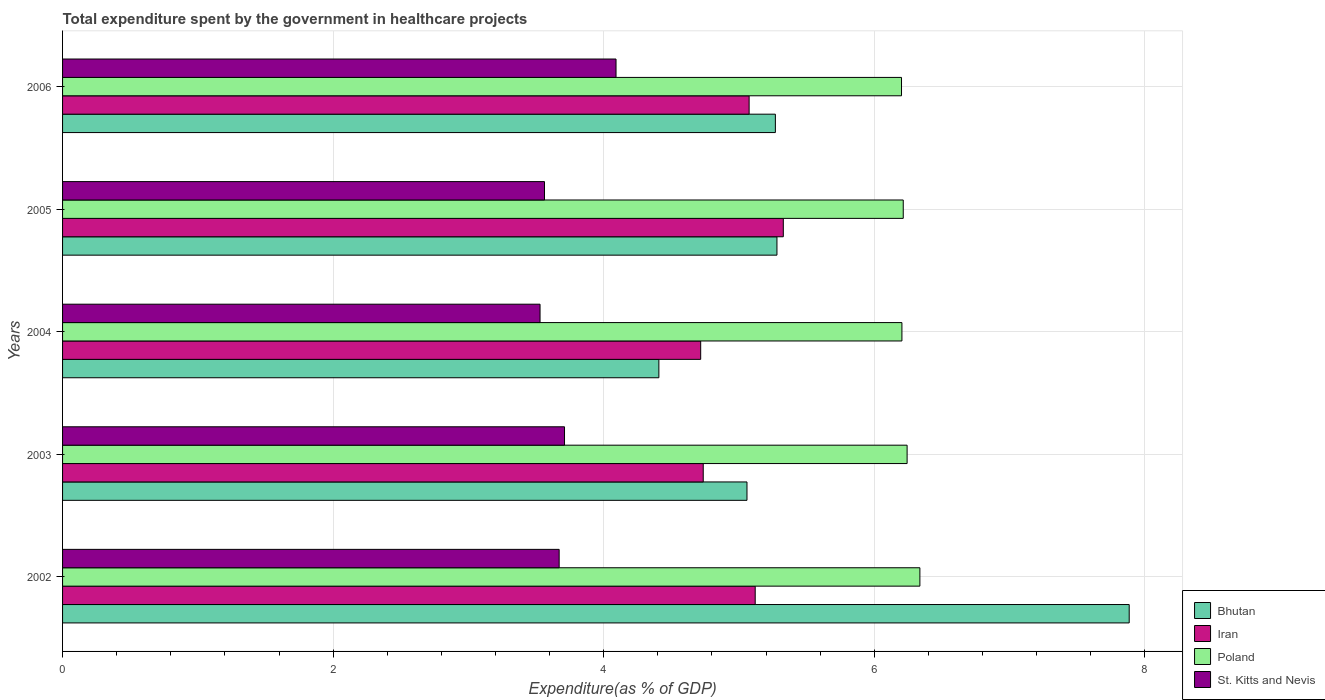How many different coloured bars are there?
Provide a succinct answer. 4. How many groups of bars are there?
Provide a succinct answer. 5. Are the number of bars per tick equal to the number of legend labels?
Give a very brief answer. Yes. How many bars are there on the 5th tick from the top?
Your answer should be very brief. 4. What is the label of the 4th group of bars from the top?
Make the answer very short. 2003. What is the total expenditure spent by the government in healthcare projects in Poland in 2006?
Your answer should be very brief. 6.2. Across all years, what is the maximum total expenditure spent by the government in healthcare projects in Poland?
Your answer should be very brief. 6.34. Across all years, what is the minimum total expenditure spent by the government in healthcare projects in St. Kitts and Nevis?
Your answer should be compact. 3.53. In which year was the total expenditure spent by the government in healthcare projects in Bhutan minimum?
Your answer should be compact. 2004. What is the total total expenditure spent by the government in healthcare projects in Bhutan in the graph?
Make the answer very short. 27.9. What is the difference between the total expenditure spent by the government in healthcare projects in Iran in 2002 and that in 2005?
Make the answer very short. -0.21. What is the difference between the total expenditure spent by the government in healthcare projects in Iran in 2005 and the total expenditure spent by the government in healthcare projects in Bhutan in 2002?
Provide a succinct answer. -2.56. What is the average total expenditure spent by the government in healthcare projects in Iran per year?
Provide a short and direct response. 4.99. In the year 2003, what is the difference between the total expenditure spent by the government in healthcare projects in Bhutan and total expenditure spent by the government in healthcare projects in St. Kitts and Nevis?
Give a very brief answer. 1.35. What is the ratio of the total expenditure spent by the government in healthcare projects in Iran in 2003 to that in 2006?
Your answer should be very brief. 0.93. Is the total expenditure spent by the government in healthcare projects in Bhutan in 2004 less than that in 2005?
Keep it short and to the point. Yes. What is the difference between the highest and the second highest total expenditure spent by the government in healthcare projects in Iran?
Your answer should be very brief. 0.21. What is the difference between the highest and the lowest total expenditure spent by the government in healthcare projects in Iran?
Offer a terse response. 0.61. In how many years, is the total expenditure spent by the government in healthcare projects in Bhutan greater than the average total expenditure spent by the government in healthcare projects in Bhutan taken over all years?
Your answer should be very brief. 1. What does the 1st bar from the top in 2004 represents?
Ensure brevity in your answer.  St. Kitts and Nevis. What does the 3rd bar from the bottom in 2005 represents?
Provide a short and direct response. Poland. Are all the bars in the graph horizontal?
Make the answer very short. Yes. How many years are there in the graph?
Keep it short and to the point. 5. What is the difference between two consecutive major ticks on the X-axis?
Provide a short and direct response. 2. Are the values on the major ticks of X-axis written in scientific E-notation?
Make the answer very short. No. Where does the legend appear in the graph?
Your answer should be compact. Bottom right. How are the legend labels stacked?
Give a very brief answer. Vertical. What is the title of the graph?
Give a very brief answer. Total expenditure spent by the government in healthcare projects. What is the label or title of the X-axis?
Offer a terse response. Expenditure(as % of GDP). What is the Expenditure(as % of GDP) in Bhutan in 2002?
Your response must be concise. 7.88. What is the Expenditure(as % of GDP) in Iran in 2002?
Give a very brief answer. 5.12. What is the Expenditure(as % of GDP) in Poland in 2002?
Your answer should be compact. 6.34. What is the Expenditure(as % of GDP) of St. Kitts and Nevis in 2002?
Provide a short and direct response. 3.67. What is the Expenditure(as % of GDP) of Bhutan in 2003?
Give a very brief answer. 5.06. What is the Expenditure(as % of GDP) in Iran in 2003?
Make the answer very short. 4.74. What is the Expenditure(as % of GDP) in Poland in 2003?
Ensure brevity in your answer.  6.24. What is the Expenditure(as % of GDP) in St. Kitts and Nevis in 2003?
Your answer should be compact. 3.71. What is the Expenditure(as % of GDP) in Bhutan in 2004?
Your response must be concise. 4.41. What is the Expenditure(as % of GDP) of Iran in 2004?
Provide a short and direct response. 4.72. What is the Expenditure(as % of GDP) of Poland in 2004?
Offer a terse response. 6.2. What is the Expenditure(as % of GDP) in St. Kitts and Nevis in 2004?
Ensure brevity in your answer.  3.53. What is the Expenditure(as % of GDP) of Bhutan in 2005?
Provide a succinct answer. 5.28. What is the Expenditure(as % of GDP) in Iran in 2005?
Make the answer very short. 5.33. What is the Expenditure(as % of GDP) of Poland in 2005?
Your answer should be compact. 6.21. What is the Expenditure(as % of GDP) in St. Kitts and Nevis in 2005?
Give a very brief answer. 3.56. What is the Expenditure(as % of GDP) of Bhutan in 2006?
Offer a terse response. 5.27. What is the Expenditure(as % of GDP) in Iran in 2006?
Make the answer very short. 5.07. What is the Expenditure(as % of GDP) in Poland in 2006?
Ensure brevity in your answer.  6.2. What is the Expenditure(as % of GDP) of St. Kitts and Nevis in 2006?
Offer a very short reply. 4.09. Across all years, what is the maximum Expenditure(as % of GDP) in Bhutan?
Your answer should be very brief. 7.88. Across all years, what is the maximum Expenditure(as % of GDP) of Iran?
Ensure brevity in your answer.  5.33. Across all years, what is the maximum Expenditure(as % of GDP) of Poland?
Give a very brief answer. 6.34. Across all years, what is the maximum Expenditure(as % of GDP) of St. Kitts and Nevis?
Your response must be concise. 4.09. Across all years, what is the minimum Expenditure(as % of GDP) in Bhutan?
Your response must be concise. 4.41. Across all years, what is the minimum Expenditure(as % of GDP) of Iran?
Your answer should be very brief. 4.72. Across all years, what is the minimum Expenditure(as % of GDP) of Poland?
Give a very brief answer. 6.2. Across all years, what is the minimum Expenditure(as % of GDP) of St. Kitts and Nevis?
Your answer should be very brief. 3.53. What is the total Expenditure(as % of GDP) in Bhutan in the graph?
Your answer should be very brief. 27.9. What is the total Expenditure(as % of GDP) in Iran in the graph?
Provide a short and direct response. 24.97. What is the total Expenditure(as % of GDP) of Poland in the graph?
Give a very brief answer. 31.2. What is the total Expenditure(as % of GDP) of St. Kitts and Nevis in the graph?
Your answer should be compact. 18.56. What is the difference between the Expenditure(as % of GDP) of Bhutan in 2002 and that in 2003?
Provide a succinct answer. 2.83. What is the difference between the Expenditure(as % of GDP) of Iran in 2002 and that in 2003?
Give a very brief answer. 0.38. What is the difference between the Expenditure(as % of GDP) of Poland in 2002 and that in 2003?
Keep it short and to the point. 0.09. What is the difference between the Expenditure(as % of GDP) of St. Kitts and Nevis in 2002 and that in 2003?
Your answer should be very brief. -0.04. What is the difference between the Expenditure(as % of GDP) in Bhutan in 2002 and that in 2004?
Provide a short and direct response. 3.48. What is the difference between the Expenditure(as % of GDP) in Iran in 2002 and that in 2004?
Your answer should be very brief. 0.4. What is the difference between the Expenditure(as % of GDP) in Poland in 2002 and that in 2004?
Offer a terse response. 0.13. What is the difference between the Expenditure(as % of GDP) in St. Kitts and Nevis in 2002 and that in 2004?
Make the answer very short. 0.14. What is the difference between the Expenditure(as % of GDP) of Bhutan in 2002 and that in 2005?
Ensure brevity in your answer.  2.6. What is the difference between the Expenditure(as % of GDP) of Iran in 2002 and that in 2005?
Keep it short and to the point. -0.21. What is the difference between the Expenditure(as % of GDP) of Poland in 2002 and that in 2005?
Provide a succinct answer. 0.12. What is the difference between the Expenditure(as % of GDP) of St. Kitts and Nevis in 2002 and that in 2005?
Offer a terse response. 0.11. What is the difference between the Expenditure(as % of GDP) in Bhutan in 2002 and that in 2006?
Your response must be concise. 2.62. What is the difference between the Expenditure(as % of GDP) of Iran in 2002 and that in 2006?
Give a very brief answer. 0.04. What is the difference between the Expenditure(as % of GDP) of Poland in 2002 and that in 2006?
Offer a terse response. 0.14. What is the difference between the Expenditure(as % of GDP) of St. Kitts and Nevis in 2002 and that in 2006?
Your answer should be compact. -0.42. What is the difference between the Expenditure(as % of GDP) of Bhutan in 2003 and that in 2004?
Offer a terse response. 0.65. What is the difference between the Expenditure(as % of GDP) in Iran in 2003 and that in 2004?
Your answer should be compact. 0.02. What is the difference between the Expenditure(as % of GDP) in Poland in 2003 and that in 2004?
Offer a terse response. 0.04. What is the difference between the Expenditure(as % of GDP) of St. Kitts and Nevis in 2003 and that in 2004?
Keep it short and to the point. 0.18. What is the difference between the Expenditure(as % of GDP) of Bhutan in 2003 and that in 2005?
Provide a succinct answer. -0.22. What is the difference between the Expenditure(as % of GDP) in Iran in 2003 and that in 2005?
Your answer should be compact. -0.59. What is the difference between the Expenditure(as % of GDP) in Poland in 2003 and that in 2005?
Your answer should be very brief. 0.03. What is the difference between the Expenditure(as % of GDP) of St. Kitts and Nevis in 2003 and that in 2005?
Offer a terse response. 0.15. What is the difference between the Expenditure(as % of GDP) of Bhutan in 2003 and that in 2006?
Provide a short and direct response. -0.21. What is the difference between the Expenditure(as % of GDP) in Iran in 2003 and that in 2006?
Provide a succinct answer. -0.34. What is the difference between the Expenditure(as % of GDP) in Poland in 2003 and that in 2006?
Keep it short and to the point. 0.04. What is the difference between the Expenditure(as % of GDP) of St. Kitts and Nevis in 2003 and that in 2006?
Offer a terse response. -0.38. What is the difference between the Expenditure(as % of GDP) of Bhutan in 2004 and that in 2005?
Keep it short and to the point. -0.87. What is the difference between the Expenditure(as % of GDP) of Iran in 2004 and that in 2005?
Give a very brief answer. -0.61. What is the difference between the Expenditure(as % of GDP) in Poland in 2004 and that in 2005?
Provide a succinct answer. -0.01. What is the difference between the Expenditure(as % of GDP) in St. Kitts and Nevis in 2004 and that in 2005?
Ensure brevity in your answer.  -0.03. What is the difference between the Expenditure(as % of GDP) in Bhutan in 2004 and that in 2006?
Provide a short and direct response. -0.86. What is the difference between the Expenditure(as % of GDP) in Iran in 2004 and that in 2006?
Offer a terse response. -0.36. What is the difference between the Expenditure(as % of GDP) in Poland in 2004 and that in 2006?
Provide a succinct answer. 0. What is the difference between the Expenditure(as % of GDP) in St. Kitts and Nevis in 2004 and that in 2006?
Keep it short and to the point. -0.56. What is the difference between the Expenditure(as % of GDP) of Bhutan in 2005 and that in 2006?
Offer a very short reply. 0.01. What is the difference between the Expenditure(as % of GDP) in Iran in 2005 and that in 2006?
Provide a short and direct response. 0.25. What is the difference between the Expenditure(as % of GDP) of Poland in 2005 and that in 2006?
Your response must be concise. 0.01. What is the difference between the Expenditure(as % of GDP) in St. Kitts and Nevis in 2005 and that in 2006?
Your answer should be compact. -0.53. What is the difference between the Expenditure(as % of GDP) of Bhutan in 2002 and the Expenditure(as % of GDP) of Iran in 2003?
Your response must be concise. 3.15. What is the difference between the Expenditure(as % of GDP) of Bhutan in 2002 and the Expenditure(as % of GDP) of Poland in 2003?
Provide a short and direct response. 1.64. What is the difference between the Expenditure(as % of GDP) in Bhutan in 2002 and the Expenditure(as % of GDP) in St. Kitts and Nevis in 2003?
Offer a terse response. 4.17. What is the difference between the Expenditure(as % of GDP) in Iran in 2002 and the Expenditure(as % of GDP) in Poland in 2003?
Your response must be concise. -1.12. What is the difference between the Expenditure(as % of GDP) of Iran in 2002 and the Expenditure(as % of GDP) of St. Kitts and Nevis in 2003?
Keep it short and to the point. 1.41. What is the difference between the Expenditure(as % of GDP) of Poland in 2002 and the Expenditure(as % of GDP) of St. Kitts and Nevis in 2003?
Offer a very short reply. 2.63. What is the difference between the Expenditure(as % of GDP) in Bhutan in 2002 and the Expenditure(as % of GDP) in Iran in 2004?
Ensure brevity in your answer.  3.17. What is the difference between the Expenditure(as % of GDP) of Bhutan in 2002 and the Expenditure(as % of GDP) of Poland in 2004?
Your response must be concise. 1.68. What is the difference between the Expenditure(as % of GDP) in Bhutan in 2002 and the Expenditure(as % of GDP) in St. Kitts and Nevis in 2004?
Give a very brief answer. 4.35. What is the difference between the Expenditure(as % of GDP) of Iran in 2002 and the Expenditure(as % of GDP) of Poland in 2004?
Keep it short and to the point. -1.08. What is the difference between the Expenditure(as % of GDP) in Iran in 2002 and the Expenditure(as % of GDP) in St. Kitts and Nevis in 2004?
Ensure brevity in your answer.  1.59. What is the difference between the Expenditure(as % of GDP) of Poland in 2002 and the Expenditure(as % of GDP) of St. Kitts and Nevis in 2004?
Offer a very short reply. 2.81. What is the difference between the Expenditure(as % of GDP) in Bhutan in 2002 and the Expenditure(as % of GDP) in Iran in 2005?
Your answer should be very brief. 2.56. What is the difference between the Expenditure(as % of GDP) of Bhutan in 2002 and the Expenditure(as % of GDP) of Poland in 2005?
Give a very brief answer. 1.67. What is the difference between the Expenditure(as % of GDP) in Bhutan in 2002 and the Expenditure(as % of GDP) in St. Kitts and Nevis in 2005?
Make the answer very short. 4.32. What is the difference between the Expenditure(as % of GDP) of Iran in 2002 and the Expenditure(as % of GDP) of Poland in 2005?
Your response must be concise. -1.09. What is the difference between the Expenditure(as % of GDP) in Iran in 2002 and the Expenditure(as % of GDP) in St. Kitts and Nevis in 2005?
Keep it short and to the point. 1.56. What is the difference between the Expenditure(as % of GDP) in Poland in 2002 and the Expenditure(as % of GDP) in St. Kitts and Nevis in 2005?
Provide a succinct answer. 2.77. What is the difference between the Expenditure(as % of GDP) of Bhutan in 2002 and the Expenditure(as % of GDP) of Iran in 2006?
Make the answer very short. 2.81. What is the difference between the Expenditure(as % of GDP) in Bhutan in 2002 and the Expenditure(as % of GDP) in Poland in 2006?
Give a very brief answer. 1.68. What is the difference between the Expenditure(as % of GDP) in Bhutan in 2002 and the Expenditure(as % of GDP) in St. Kitts and Nevis in 2006?
Keep it short and to the point. 3.79. What is the difference between the Expenditure(as % of GDP) in Iran in 2002 and the Expenditure(as % of GDP) in Poland in 2006?
Offer a very short reply. -1.08. What is the difference between the Expenditure(as % of GDP) in Iran in 2002 and the Expenditure(as % of GDP) in St. Kitts and Nevis in 2006?
Offer a terse response. 1.03. What is the difference between the Expenditure(as % of GDP) of Poland in 2002 and the Expenditure(as % of GDP) of St. Kitts and Nevis in 2006?
Give a very brief answer. 2.25. What is the difference between the Expenditure(as % of GDP) of Bhutan in 2003 and the Expenditure(as % of GDP) of Iran in 2004?
Keep it short and to the point. 0.34. What is the difference between the Expenditure(as % of GDP) of Bhutan in 2003 and the Expenditure(as % of GDP) of Poland in 2004?
Your answer should be very brief. -1.15. What is the difference between the Expenditure(as % of GDP) in Bhutan in 2003 and the Expenditure(as % of GDP) in St. Kitts and Nevis in 2004?
Provide a succinct answer. 1.53. What is the difference between the Expenditure(as % of GDP) of Iran in 2003 and the Expenditure(as % of GDP) of Poland in 2004?
Make the answer very short. -1.47. What is the difference between the Expenditure(as % of GDP) in Iran in 2003 and the Expenditure(as % of GDP) in St. Kitts and Nevis in 2004?
Keep it short and to the point. 1.21. What is the difference between the Expenditure(as % of GDP) of Poland in 2003 and the Expenditure(as % of GDP) of St. Kitts and Nevis in 2004?
Offer a terse response. 2.71. What is the difference between the Expenditure(as % of GDP) of Bhutan in 2003 and the Expenditure(as % of GDP) of Iran in 2005?
Your answer should be compact. -0.27. What is the difference between the Expenditure(as % of GDP) of Bhutan in 2003 and the Expenditure(as % of GDP) of Poland in 2005?
Give a very brief answer. -1.16. What is the difference between the Expenditure(as % of GDP) in Bhutan in 2003 and the Expenditure(as % of GDP) in St. Kitts and Nevis in 2005?
Keep it short and to the point. 1.5. What is the difference between the Expenditure(as % of GDP) in Iran in 2003 and the Expenditure(as % of GDP) in Poland in 2005?
Offer a very short reply. -1.48. What is the difference between the Expenditure(as % of GDP) of Iran in 2003 and the Expenditure(as % of GDP) of St. Kitts and Nevis in 2005?
Provide a succinct answer. 1.17. What is the difference between the Expenditure(as % of GDP) of Poland in 2003 and the Expenditure(as % of GDP) of St. Kitts and Nevis in 2005?
Provide a succinct answer. 2.68. What is the difference between the Expenditure(as % of GDP) of Bhutan in 2003 and the Expenditure(as % of GDP) of Iran in 2006?
Give a very brief answer. -0.02. What is the difference between the Expenditure(as % of GDP) in Bhutan in 2003 and the Expenditure(as % of GDP) in Poland in 2006?
Provide a short and direct response. -1.14. What is the difference between the Expenditure(as % of GDP) in Bhutan in 2003 and the Expenditure(as % of GDP) in St. Kitts and Nevis in 2006?
Provide a short and direct response. 0.97. What is the difference between the Expenditure(as % of GDP) of Iran in 2003 and the Expenditure(as % of GDP) of Poland in 2006?
Provide a succinct answer. -1.47. What is the difference between the Expenditure(as % of GDP) in Iran in 2003 and the Expenditure(as % of GDP) in St. Kitts and Nevis in 2006?
Offer a very short reply. 0.64. What is the difference between the Expenditure(as % of GDP) of Poland in 2003 and the Expenditure(as % of GDP) of St. Kitts and Nevis in 2006?
Provide a succinct answer. 2.15. What is the difference between the Expenditure(as % of GDP) of Bhutan in 2004 and the Expenditure(as % of GDP) of Iran in 2005?
Offer a terse response. -0.92. What is the difference between the Expenditure(as % of GDP) of Bhutan in 2004 and the Expenditure(as % of GDP) of Poland in 2005?
Provide a succinct answer. -1.81. What is the difference between the Expenditure(as % of GDP) in Bhutan in 2004 and the Expenditure(as % of GDP) in St. Kitts and Nevis in 2005?
Give a very brief answer. 0.85. What is the difference between the Expenditure(as % of GDP) of Iran in 2004 and the Expenditure(as % of GDP) of Poland in 2005?
Offer a very short reply. -1.5. What is the difference between the Expenditure(as % of GDP) of Iran in 2004 and the Expenditure(as % of GDP) of St. Kitts and Nevis in 2005?
Your answer should be compact. 1.15. What is the difference between the Expenditure(as % of GDP) of Poland in 2004 and the Expenditure(as % of GDP) of St. Kitts and Nevis in 2005?
Give a very brief answer. 2.64. What is the difference between the Expenditure(as % of GDP) of Bhutan in 2004 and the Expenditure(as % of GDP) of Iran in 2006?
Ensure brevity in your answer.  -0.67. What is the difference between the Expenditure(as % of GDP) in Bhutan in 2004 and the Expenditure(as % of GDP) in Poland in 2006?
Offer a very short reply. -1.79. What is the difference between the Expenditure(as % of GDP) in Bhutan in 2004 and the Expenditure(as % of GDP) in St. Kitts and Nevis in 2006?
Offer a very short reply. 0.32. What is the difference between the Expenditure(as % of GDP) in Iran in 2004 and the Expenditure(as % of GDP) in Poland in 2006?
Ensure brevity in your answer.  -1.48. What is the difference between the Expenditure(as % of GDP) in Iran in 2004 and the Expenditure(as % of GDP) in St. Kitts and Nevis in 2006?
Your answer should be compact. 0.63. What is the difference between the Expenditure(as % of GDP) of Poland in 2004 and the Expenditure(as % of GDP) of St. Kitts and Nevis in 2006?
Keep it short and to the point. 2.11. What is the difference between the Expenditure(as % of GDP) in Bhutan in 2005 and the Expenditure(as % of GDP) in Iran in 2006?
Make the answer very short. 0.21. What is the difference between the Expenditure(as % of GDP) in Bhutan in 2005 and the Expenditure(as % of GDP) in Poland in 2006?
Provide a succinct answer. -0.92. What is the difference between the Expenditure(as % of GDP) in Bhutan in 2005 and the Expenditure(as % of GDP) in St. Kitts and Nevis in 2006?
Provide a succinct answer. 1.19. What is the difference between the Expenditure(as % of GDP) of Iran in 2005 and the Expenditure(as % of GDP) of Poland in 2006?
Your answer should be very brief. -0.87. What is the difference between the Expenditure(as % of GDP) in Iran in 2005 and the Expenditure(as % of GDP) in St. Kitts and Nevis in 2006?
Keep it short and to the point. 1.24. What is the difference between the Expenditure(as % of GDP) of Poland in 2005 and the Expenditure(as % of GDP) of St. Kitts and Nevis in 2006?
Offer a very short reply. 2.12. What is the average Expenditure(as % of GDP) in Bhutan per year?
Make the answer very short. 5.58. What is the average Expenditure(as % of GDP) in Iran per year?
Give a very brief answer. 4.99. What is the average Expenditure(as % of GDP) of Poland per year?
Keep it short and to the point. 6.24. What is the average Expenditure(as % of GDP) of St. Kitts and Nevis per year?
Your answer should be very brief. 3.71. In the year 2002, what is the difference between the Expenditure(as % of GDP) of Bhutan and Expenditure(as % of GDP) of Iran?
Keep it short and to the point. 2.76. In the year 2002, what is the difference between the Expenditure(as % of GDP) in Bhutan and Expenditure(as % of GDP) in Poland?
Provide a short and direct response. 1.55. In the year 2002, what is the difference between the Expenditure(as % of GDP) in Bhutan and Expenditure(as % of GDP) in St. Kitts and Nevis?
Make the answer very short. 4.21. In the year 2002, what is the difference between the Expenditure(as % of GDP) in Iran and Expenditure(as % of GDP) in Poland?
Keep it short and to the point. -1.22. In the year 2002, what is the difference between the Expenditure(as % of GDP) of Iran and Expenditure(as % of GDP) of St. Kitts and Nevis?
Offer a terse response. 1.45. In the year 2002, what is the difference between the Expenditure(as % of GDP) of Poland and Expenditure(as % of GDP) of St. Kitts and Nevis?
Your answer should be very brief. 2.67. In the year 2003, what is the difference between the Expenditure(as % of GDP) of Bhutan and Expenditure(as % of GDP) of Iran?
Offer a terse response. 0.32. In the year 2003, what is the difference between the Expenditure(as % of GDP) of Bhutan and Expenditure(as % of GDP) of Poland?
Your response must be concise. -1.18. In the year 2003, what is the difference between the Expenditure(as % of GDP) of Bhutan and Expenditure(as % of GDP) of St. Kitts and Nevis?
Offer a terse response. 1.35. In the year 2003, what is the difference between the Expenditure(as % of GDP) in Iran and Expenditure(as % of GDP) in Poland?
Keep it short and to the point. -1.51. In the year 2003, what is the difference between the Expenditure(as % of GDP) in Iran and Expenditure(as % of GDP) in St. Kitts and Nevis?
Your answer should be compact. 1.03. In the year 2003, what is the difference between the Expenditure(as % of GDP) in Poland and Expenditure(as % of GDP) in St. Kitts and Nevis?
Provide a succinct answer. 2.53. In the year 2004, what is the difference between the Expenditure(as % of GDP) in Bhutan and Expenditure(as % of GDP) in Iran?
Your answer should be compact. -0.31. In the year 2004, what is the difference between the Expenditure(as % of GDP) of Bhutan and Expenditure(as % of GDP) of Poland?
Provide a succinct answer. -1.8. In the year 2004, what is the difference between the Expenditure(as % of GDP) of Bhutan and Expenditure(as % of GDP) of St. Kitts and Nevis?
Your answer should be compact. 0.88. In the year 2004, what is the difference between the Expenditure(as % of GDP) of Iran and Expenditure(as % of GDP) of Poland?
Give a very brief answer. -1.49. In the year 2004, what is the difference between the Expenditure(as % of GDP) of Iran and Expenditure(as % of GDP) of St. Kitts and Nevis?
Offer a very short reply. 1.19. In the year 2004, what is the difference between the Expenditure(as % of GDP) of Poland and Expenditure(as % of GDP) of St. Kitts and Nevis?
Offer a terse response. 2.67. In the year 2005, what is the difference between the Expenditure(as % of GDP) of Bhutan and Expenditure(as % of GDP) of Iran?
Ensure brevity in your answer.  -0.05. In the year 2005, what is the difference between the Expenditure(as % of GDP) in Bhutan and Expenditure(as % of GDP) in Poland?
Give a very brief answer. -0.93. In the year 2005, what is the difference between the Expenditure(as % of GDP) in Bhutan and Expenditure(as % of GDP) in St. Kitts and Nevis?
Provide a succinct answer. 1.72. In the year 2005, what is the difference between the Expenditure(as % of GDP) in Iran and Expenditure(as % of GDP) in Poland?
Offer a terse response. -0.89. In the year 2005, what is the difference between the Expenditure(as % of GDP) in Iran and Expenditure(as % of GDP) in St. Kitts and Nevis?
Offer a very short reply. 1.77. In the year 2005, what is the difference between the Expenditure(as % of GDP) of Poland and Expenditure(as % of GDP) of St. Kitts and Nevis?
Provide a short and direct response. 2.65. In the year 2006, what is the difference between the Expenditure(as % of GDP) of Bhutan and Expenditure(as % of GDP) of Iran?
Provide a succinct answer. 0.19. In the year 2006, what is the difference between the Expenditure(as % of GDP) of Bhutan and Expenditure(as % of GDP) of Poland?
Keep it short and to the point. -0.93. In the year 2006, what is the difference between the Expenditure(as % of GDP) in Bhutan and Expenditure(as % of GDP) in St. Kitts and Nevis?
Your answer should be very brief. 1.18. In the year 2006, what is the difference between the Expenditure(as % of GDP) of Iran and Expenditure(as % of GDP) of Poland?
Keep it short and to the point. -1.13. In the year 2006, what is the difference between the Expenditure(as % of GDP) in Iran and Expenditure(as % of GDP) in St. Kitts and Nevis?
Provide a short and direct response. 0.98. In the year 2006, what is the difference between the Expenditure(as % of GDP) in Poland and Expenditure(as % of GDP) in St. Kitts and Nevis?
Offer a terse response. 2.11. What is the ratio of the Expenditure(as % of GDP) of Bhutan in 2002 to that in 2003?
Ensure brevity in your answer.  1.56. What is the ratio of the Expenditure(as % of GDP) of Iran in 2002 to that in 2003?
Provide a succinct answer. 1.08. What is the ratio of the Expenditure(as % of GDP) in Poland in 2002 to that in 2003?
Offer a terse response. 1.02. What is the ratio of the Expenditure(as % of GDP) in St. Kitts and Nevis in 2002 to that in 2003?
Keep it short and to the point. 0.99. What is the ratio of the Expenditure(as % of GDP) in Bhutan in 2002 to that in 2004?
Your response must be concise. 1.79. What is the ratio of the Expenditure(as % of GDP) in Iran in 2002 to that in 2004?
Make the answer very short. 1.09. What is the ratio of the Expenditure(as % of GDP) of Poland in 2002 to that in 2004?
Your answer should be very brief. 1.02. What is the ratio of the Expenditure(as % of GDP) in Bhutan in 2002 to that in 2005?
Keep it short and to the point. 1.49. What is the ratio of the Expenditure(as % of GDP) in Iran in 2002 to that in 2005?
Ensure brevity in your answer.  0.96. What is the ratio of the Expenditure(as % of GDP) in Poland in 2002 to that in 2005?
Make the answer very short. 1.02. What is the ratio of the Expenditure(as % of GDP) of St. Kitts and Nevis in 2002 to that in 2005?
Your answer should be very brief. 1.03. What is the ratio of the Expenditure(as % of GDP) of Bhutan in 2002 to that in 2006?
Ensure brevity in your answer.  1.5. What is the ratio of the Expenditure(as % of GDP) in Iran in 2002 to that in 2006?
Make the answer very short. 1.01. What is the ratio of the Expenditure(as % of GDP) in Poland in 2002 to that in 2006?
Ensure brevity in your answer.  1.02. What is the ratio of the Expenditure(as % of GDP) in St. Kitts and Nevis in 2002 to that in 2006?
Ensure brevity in your answer.  0.9. What is the ratio of the Expenditure(as % of GDP) of Bhutan in 2003 to that in 2004?
Keep it short and to the point. 1.15. What is the ratio of the Expenditure(as % of GDP) of Iran in 2003 to that in 2004?
Make the answer very short. 1. What is the ratio of the Expenditure(as % of GDP) of Poland in 2003 to that in 2004?
Give a very brief answer. 1.01. What is the ratio of the Expenditure(as % of GDP) of St. Kitts and Nevis in 2003 to that in 2004?
Provide a short and direct response. 1.05. What is the ratio of the Expenditure(as % of GDP) in Bhutan in 2003 to that in 2005?
Your answer should be compact. 0.96. What is the ratio of the Expenditure(as % of GDP) in Iran in 2003 to that in 2005?
Make the answer very short. 0.89. What is the ratio of the Expenditure(as % of GDP) in St. Kitts and Nevis in 2003 to that in 2005?
Your response must be concise. 1.04. What is the ratio of the Expenditure(as % of GDP) in Bhutan in 2003 to that in 2006?
Make the answer very short. 0.96. What is the ratio of the Expenditure(as % of GDP) of Iran in 2003 to that in 2006?
Make the answer very short. 0.93. What is the ratio of the Expenditure(as % of GDP) in Poland in 2003 to that in 2006?
Your answer should be compact. 1.01. What is the ratio of the Expenditure(as % of GDP) in St. Kitts and Nevis in 2003 to that in 2006?
Provide a succinct answer. 0.91. What is the ratio of the Expenditure(as % of GDP) in Bhutan in 2004 to that in 2005?
Keep it short and to the point. 0.83. What is the ratio of the Expenditure(as % of GDP) of Iran in 2004 to that in 2005?
Your answer should be compact. 0.89. What is the ratio of the Expenditure(as % of GDP) of Poland in 2004 to that in 2005?
Offer a very short reply. 1. What is the ratio of the Expenditure(as % of GDP) in St. Kitts and Nevis in 2004 to that in 2005?
Your answer should be very brief. 0.99. What is the ratio of the Expenditure(as % of GDP) in Bhutan in 2004 to that in 2006?
Your answer should be compact. 0.84. What is the ratio of the Expenditure(as % of GDP) in Iran in 2004 to that in 2006?
Your answer should be very brief. 0.93. What is the ratio of the Expenditure(as % of GDP) in St. Kitts and Nevis in 2004 to that in 2006?
Make the answer very short. 0.86. What is the ratio of the Expenditure(as % of GDP) in Bhutan in 2005 to that in 2006?
Your answer should be compact. 1. What is the ratio of the Expenditure(as % of GDP) of Iran in 2005 to that in 2006?
Keep it short and to the point. 1.05. What is the ratio of the Expenditure(as % of GDP) in Poland in 2005 to that in 2006?
Offer a terse response. 1. What is the ratio of the Expenditure(as % of GDP) in St. Kitts and Nevis in 2005 to that in 2006?
Make the answer very short. 0.87. What is the difference between the highest and the second highest Expenditure(as % of GDP) of Bhutan?
Keep it short and to the point. 2.6. What is the difference between the highest and the second highest Expenditure(as % of GDP) of Iran?
Your answer should be very brief. 0.21. What is the difference between the highest and the second highest Expenditure(as % of GDP) in Poland?
Your answer should be very brief. 0.09. What is the difference between the highest and the second highest Expenditure(as % of GDP) in St. Kitts and Nevis?
Your answer should be compact. 0.38. What is the difference between the highest and the lowest Expenditure(as % of GDP) in Bhutan?
Offer a terse response. 3.48. What is the difference between the highest and the lowest Expenditure(as % of GDP) in Iran?
Offer a terse response. 0.61. What is the difference between the highest and the lowest Expenditure(as % of GDP) of Poland?
Provide a succinct answer. 0.14. What is the difference between the highest and the lowest Expenditure(as % of GDP) in St. Kitts and Nevis?
Keep it short and to the point. 0.56. 